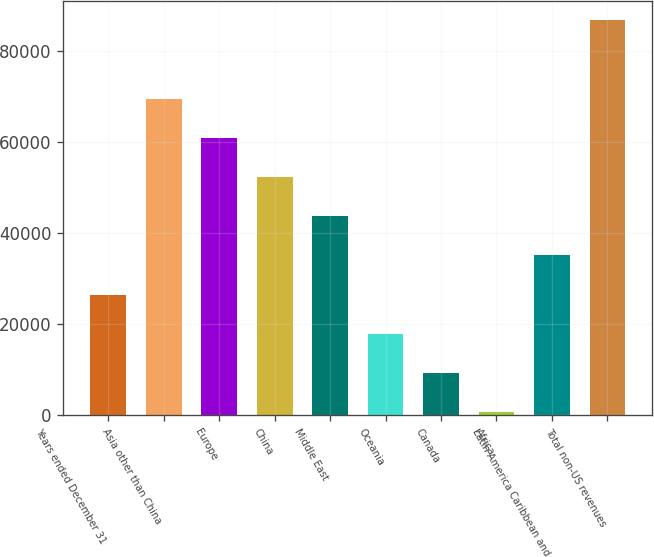Convert chart to OTSL. <chart><loc_0><loc_0><loc_500><loc_500><bar_chart><fcel>Years ended December 31<fcel>Asia other than China<fcel>Europe<fcel>China<fcel>Middle East<fcel>Oceania<fcel>Canada<fcel>Africa<fcel>Latin America Caribbean and<fcel>Total non-US revenues<nl><fcel>26421.6<fcel>69422.6<fcel>60822.4<fcel>52222.2<fcel>43622<fcel>17821.4<fcel>9221.2<fcel>621<fcel>35021.8<fcel>86623<nl></chart> 